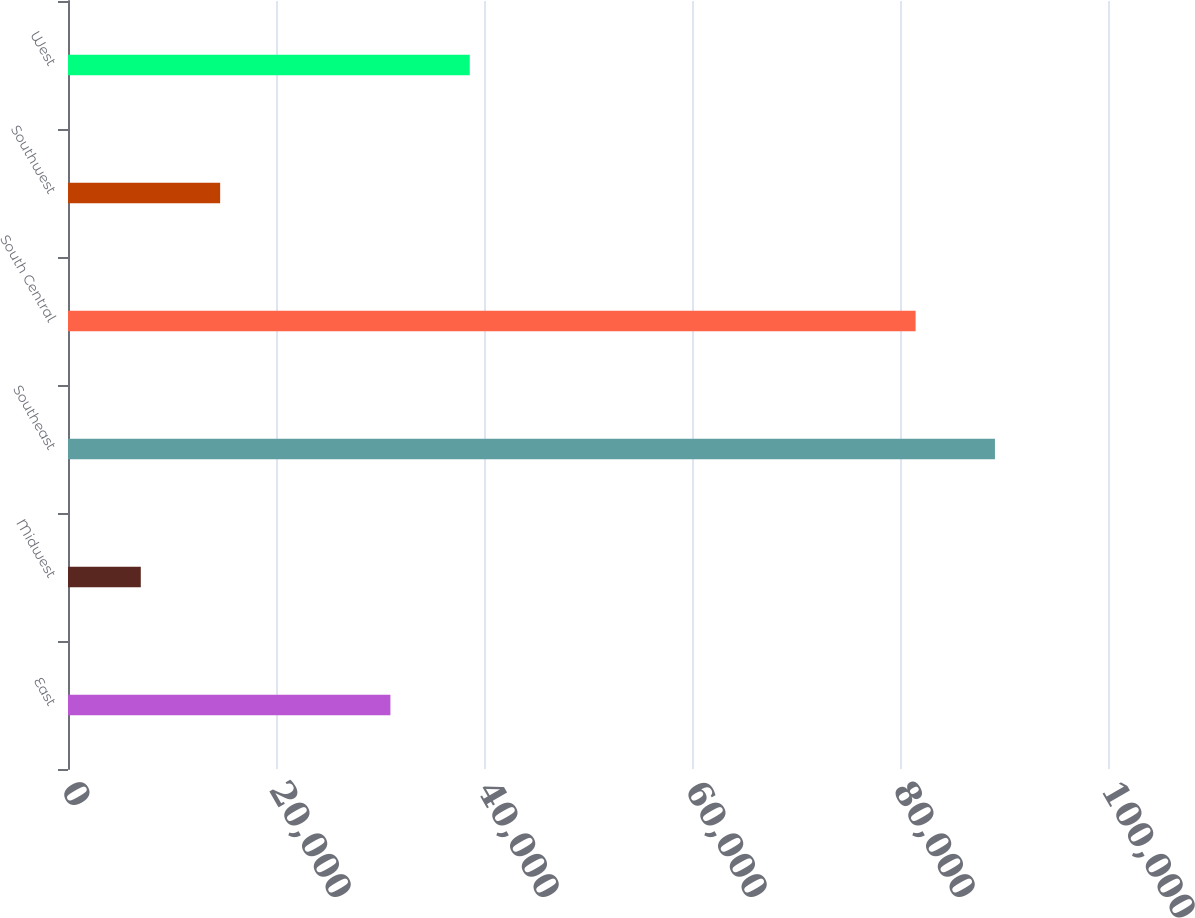Convert chart. <chart><loc_0><loc_0><loc_500><loc_500><bar_chart><fcel>East<fcel>Midwest<fcel>Southeast<fcel>South Central<fcel>Southwest<fcel>West<nl><fcel>31000<fcel>7000<fcel>89130<fcel>81500<fcel>14630<fcel>38630<nl></chart> 